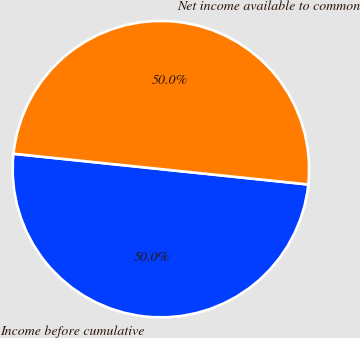<chart> <loc_0><loc_0><loc_500><loc_500><pie_chart><fcel>Income before cumulative<fcel>Net income available to common<nl><fcel>50.0%<fcel>50.0%<nl></chart> 